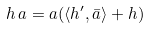<formula> <loc_0><loc_0><loc_500><loc_500>h \, a = a ( \langle h ^ { \prime } , \bar { a } \rangle + h )</formula> 